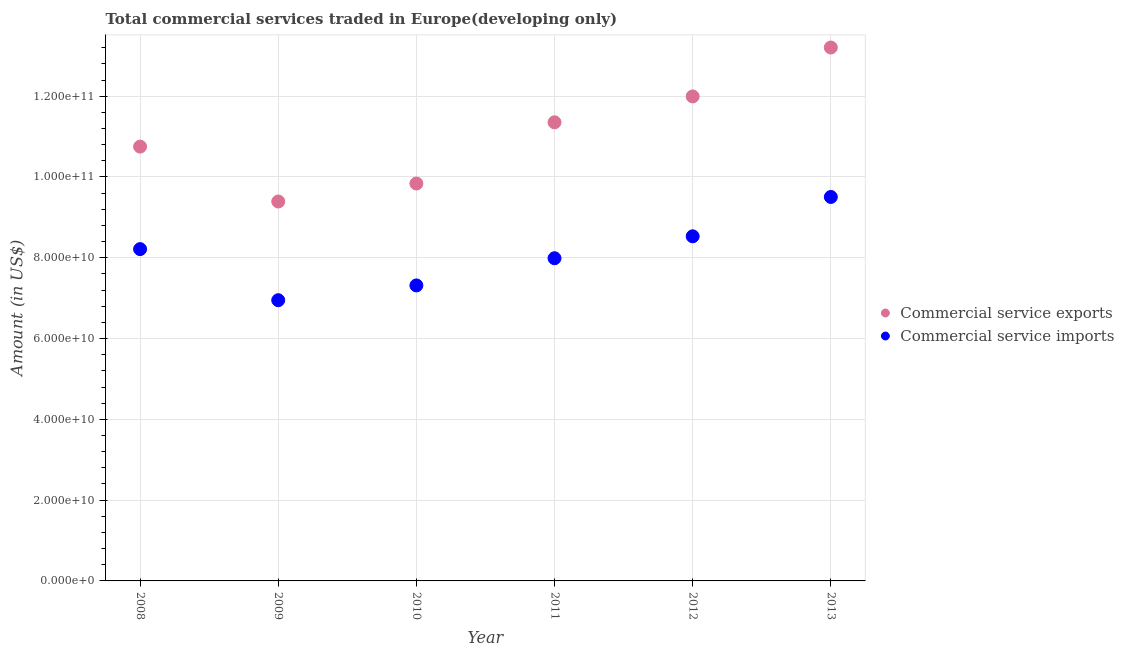How many different coloured dotlines are there?
Make the answer very short. 2. What is the amount of commercial service imports in 2011?
Give a very brief answer. 7.99e+1. Across all years, what is the maximum amount of commercial service imports?
Keep it short and to the point. 9.51e+1. Across all years, what is the minimum amount of commercial service exports?
Make the answer very short. 9.39e+1. In which year was the amount of commercial service exports maximum?
Your response must be concise. 2013. In which year was the amount of commercial service exports minimum?
Make the answer very short. 2009. What is the total amount of commercial service exports in the graph?
Your answer should be very brief. 6.65e+11. What is the difference between the amount of commercial service imports in 2008 and that in 2012?
Keep it short and to the point. -3.17e+09. What is the difference between the amount of commercial service exports in 2010 and the amount of commercial service imports in 2012?
Offer a very short reply. 1.31e+1. What is the average amount of commercial service imports per year?
Your answer should be very brief. 8.08e+1. In the year 2011, what is the difference between the amount of commercial service imports and amount of commercial service exports?
Keep it short and to the point. -3.36e+1. What is the ratio of the amount of commercial service exports in 2009 to that in 2011?
Give a very brief answer. 0.83. Is the amount of commercial service exports in 2008 less than that in 2013?
Provide a short and direct response. Yes. Is the difference between the amount of commercial service imports in 2010 and 2013 greater than the difference between the amount of commercial service exports in 2010 and 2013?
Keep it short and to the point. Yes. What is the difference between the highest and the second highest amount of commercial service exports?
Your answer should be compact. 1.21e+1. What is the difference between the highest and the lowest amount of commercial service imports?
Your answer should be very brief. 2.56e+1. Is the sum of the amount of commercial service exports in 2008 and 2010 greater than the maximum amount of commercial service imports across all years?
Make the answer very short. Yes. How many dotlines are there?
Offer a terse response. 2. How many years are there in the graph?
Offer a terse response. 6. Where does the legend appear in the graph?
Your answer should be very brief. Center right. How many legend labels are there?
Offer a terse response. 2. How are the legend labels stacked?
Offer a terse response. Vertical. What is the title of the graph?
Make the answer very short. Total commercial services traded in Europe(developing only). Does "Investment in Transport" appear as one of the legend labels in the graph?
Your response must be concise. No. What is the Amount (in US$) of Commercial service exports in 2008?
Offer a very short reply. 1.08e+11. What is the Amount (in US$) of Commercial service imports in 2008?
Provide a short and direct response. 8.21e+1. What is the Amount (in US$) of Commercial service exports in 2009?
Make the answer very short. 9.39e+1. What is the Amount (in US$) of Commercial service imports in 2009?
Your answer should be very brief. 6.95e+1. What is the Amount (in US$) in Commercial service exports in 2010?
Your response must be concise. 9.84e+1. What is the Amount (in US$) in Commercial service imports in 2010?
Give a very brief answer. 7.32e+1. What is the Amount (in US$) in Commercial service exports in 2011?
Offer a very short reply. 1.14e+11. What is the Amount (in US$) in Commercial service imports in 2011?
Offer a very short reply. 7.99e+1. What is the Amount (in US$) of Commercial service exports in 2012?
Provide a succinct answer. 1.20e+11. What is the Amount (in US$) in Commercial service imports in 2012?
Offer a terse response. 8.53e+1. What is the Amount (in US$) of Commercial service exports in 2013?
Offer a terse response. 1.32e+11. What is the Amount (in US$) in Commercial service imports in 2013?
Your answer should be very brief. 9.51e+1. Across all years, what is the maximum Amount (in US$) of Commercial service exports?
Give a very brief answer. 1.32e+11. Across all years, what is the maximum Amount (in US$) of Commercial service imports?
Offer a very short reply. 9.51e+1. Across all years, what is the minimum Amount (in US$) of Commercial service exports?
Your answer should be compact. 9.39e+1. Across all years, what is the minimum Amount (in US$) of Commercial service imports?
Your answer should be very brief. 6.95e+1. What is the total Amount (in US$) in Commercial service exports in the graph?
Offer a terse response. 6.65e+11. What is the total Amount (in US$) of Commercial service imports in the graph?
Offer a very short reply. 4.85e+11. What is the difference between the Amount (in US$) in Commercial service exports in 2008 and that in 2009?
Provide a short and direct response. 1.36e+1. What is the difference between the Amount (in US$) of Commercial service imports in 2008 and that in 2009?
Give a very brief answer. 1.26e+1. What is the difference between the Amount (in US$) in Commercial service exports in 2008 and that in 2010?
Offer a terse response. 9.14e+09. What is the difference between the Amount (in US$) in Commercial service imports in 2008 and that in 2010?
Provide a succinct answer. 8.99e+09. What is the difference between the Amount (in US$) in Commercial service exports in 2008 and that in 2011?
Provide a succinct answer. -6.02e+09. What is the difference between the Amount (in US$) of Commercial service imports in 2008 and that in 2011?
Provide a short and direct response. 2.25e+09. What is the difference between the Amount (in US$) in Commercial service exports in 2008 and that in 2012?
Make the answer very short. -1.24e+1. What is the difference between the Amount (in US$) in Commercial service imports in 2008 and that in 2012?
Your answer should be very brief. -3.17e+09. What is the difference between the Amount (in US$) in Commercial service exports in 2008 and that in 2013?
Keep it short and to the point. -2.45e+1. What is the difference between the Amount (in US$) of Commercial service imports in 2008 and that in 2013?
Ensure brevity in your answer.  -1.29e+1. What is the difference between the Amount (in US$) in Commercial service exports in 2009 and that in 2010?
Your response must be concise. -4.45e+09. What is the difference between the Amount (in US$) in Commercial service imports in 2009 and that in 2010?
Provide a succinct answer. -3.66e+09. What is the difference between the Amount (in US$) of Commercial service exports in 2009 and that in 2011?
Your response must be concise. -1.96e+1. What is the difference between the Amount (in US$) of Commercial service imports in 2009 and that in 2011?
Ensure brevity in your answer.  -1.04e+1. What is the difference between the Amount (in US$) of Commercial service exports in 2009 and that in 2012?
Keep it short and to the point. -2.60e+1. What is the difference between the Amount (in US$) of Commercial service imports in 2009 and that in 2012?
Provide a short and direct response. -1.58e+1. What is the difference between the Amount (in US$) of Commercial service exports in 2009 and that in 2013?
Provide a short and direct response. -3.81e+1. What is the difference between the Amount (in US$) of Commercial service imports in 2009 and that in 2013?
Provide a succinct answer. -2.56e+1. What is the difference between the Amount (in US$) in Commercial service exports in 2010 and that in 2011?
Provide a short and direct response. -1.52e+1. What is the difference between the Amount (in US$) of Commercial service imports in 2010 and that in 2011?
Your answer should be compact. -6.73e+09. What is the difference between the Amount (in US$) of Commercial service exports in 2010 and that in 2012?
Provide a succinct answer. -2.16e+1. What is the difference between the Amount (in US$) of Commercial service imports in 2010 and that in 2012?
Your answer should be compact. -1.22e+1. What is the difference between the Amount (in US$) of Commercial service exports in 2010 and that in 2013?
Keep it short and to the point. -3.37e+1. What is the difference between the Amount (in US$) of Commercial service imports in 2010 and that in 2013?
Your response must be concise. -2.19e+1. What is the difference between the Amount (in US$) of Commercial service exports in 2011 and that in 2012?
Ensure brevity in your answer.  -6.41e+09. What is the difference between the Amount (in US$) in Commercial service imports in 2011 and that in 2012?
Give a very brief answer. -5.42e+09. What is the difference between the Amount (in US$) of Commercial service exports in 2011 and that in 2013?
Your answer should be compact. -1.85e+1. What is the difference between the Amount (in US$) in Commercial service imports in 2011 and that in 2013?
Offer a terse response. -1.52e+1. What is the difference between the Amount (in US$) in Commercial service exports in 2012 and that in 2013?
Your answer should be very brief. -1.21e+1. What is the difference between the Amount (in US$) of Commercial service imports in 2012 and that in 2013?
Keep it short and to the point. -9.74e+09. What is the difference between the Amount (in US$) of Commercial service exports in 2008 and the Amount (in US$) of Commercial service imports in 2009?
Provide a succinct answer. 3.80e+1. What is the difference between the Amount (in US$) of Commercial service exports in 2008 and the Amount (in US$) of Commercial service imports in 2010?
Keep it short and to the point. 3.44e+1. What is the difference between the Amount (in US$) in Commercial service exports in 2008 and the Amount (in US$) in Commercial service imports in 2011?
Provide a succinct answer. 2.76e+1. What is the difference between the Amount (in US$) in Commercial service exports in 2008 and the Amount (in US$) in Commercial service imports in 2012?
Offer a very short reply. 2.22e+1. What is the difference between the Amount (in US$) of Commercial service exports in 2008 and the Amount (in US$) of Commercial service imports in 2013?
Provide a short and direct response. 1.25e+1. What is the difference between the Amount (in US$) in Commercial service exports in 2009 and the Amount (in US$) in Commercial service imports in 2010?
Give a very brief answer. 2.08e+1. What is the difference between the Amount (in US$) of Commercial service exports in 2009 and the Amount (in US$) of Commercial service imports in 2011?
Make the answer very short. 1.40e+1. What is the difference between the Amount (in US$) of Commercial service exports in 2009 and the Amount (in US$) of Commercial service imports in 2012?
Your response must be concise. 8.61e+09. What is the difference between the Amount (in US$) in Commercial service exports in 2009 and the Amount (in US$) in Commercial service imports in 2013?
Ensure brevity in your answer.  -1.13e+09. What is the difference between the Amount (in US$) of Commercial service exports in 2010 and the Amount (in US$) of Commercial service imports in 2011?
Give a very brief answer. 1.85e+1. What is the difference between the Amount (in US$) in Commercial service exports in 2010 and the Amount (in US$) in Commercial service imports in 2012?
Give a very brief answer. 1.31e+1. What is the difference between the Amount (in US$) of Commercial service exports in 2010 and the Amount (in US$) of Commercial service imports in 2013?
Provide a short and direct response. 3.32e+09. What is the difference between the Amount (in US$) of Commercial service exports in 2011 and the Amount (in US$) of Commercial service imports in 2012?
Provide a short and direct response. 2.82e+1. What is the difference between the Amount (in US$) of Commercial service exports in 2011 and the Amount (in US$) of Commercial service imports in 2013?
Offer a very short reply. 1.85e+1. What is the difference between the Amount (in US$) of Commercial service exports in 2012 and the Amount (in US$) of Commercial service imports in 2013?
Make the answer very short. 2.49e+1. What is the average Amount (in US$) in Commercial service exports per year?
Provide a short and direct response. 1.11e+11. What is the average Amount (in US$) in Commercial service imports per year?
Offer a very short reply. 8.08e+1. In the year 2008, what is the difference between the Amount (in US$) of Commercial service exports and Amount (in US$) of Commercial service imports?
Keep it short and to the point. 2.54e+1. In the year 2009, what is the difference between the Amount (in US$) in Commercial service exports and Amount (in US$) in Commercial service imports?
Provide a short and direct response. 2.44e+1. In the year 2010, what is the difference between the Amount (in US$) in Commercial service exports and Amount (in US$) in Commercial service imports?
Provide a short and direct response. 2.52e+1. In the year 2011, what is the difference between the Amount (in US$) in Commercial service exports and Amount (in US$) in Commercial service imports?
Ensure brevity in your answer.  3.36e+1. In the year 2012, what is the difference between the Amount (in US$) in Commercial service exports and Amount (in US$) in Commercial service imports?
Provide a succinct answer. 3.46e+1. In the year 2013, what is the difference between the Amount (in US$) of Commercial service exports and Amount (in US$) of Commercial service imports?
Offer a terse response. 3.70e+1. What is the ratio of the Amount (in US$) in Commercial service exports in 2008 to that in 2009?
Keep it short and to the point. 1.14. What is the ratio of the Amount (in US$) in Commercial service imports in 2008 to that in 2009?
Make the answer very short. 1.18. What is the ratio of the Amount (in US$) in Commercial service exports in 2008 to that in 2010?
Your answer should be compact. 1.09. What is the ratio of the Amount (in US$) in Commercial service imports in 2008 to that in 2010?
Provide a succinct answer. 1.12. What is the ratio of the Amount (in US$) in Commercial service exports in 2008 to that in 2011?
Keep it short and to the point. 0.95. What is the ratio of the Amount (in US$) of Commercial service imports in 2008 to that in 2011?
Make the answer very short. 1.03. What is the ratio of the Amount (in US$) of Commercial service exports in 2008 to that in 2012?
Your answer should be very brief. 0.9. What is the ratio of the Amount (in US$) of Commercial service imports in 2008 to that in 2012?
Provide a succinct answer. 0.96. What is the ratio of the Amount (in US$) of Commercial service exports in 2008 to that in 2013?
Your response must be concise. 0.81. What is the ratio of the Amount (in US$) in Commercial service imports in 2008 to that in 2013?
Your response must be concise. 0.86. What is the ratio of the Amount (in US$) of Commercial service exports in 2009 to that in 2010?
Ensure brevity in your answer.  0.95. What is the ratio of the Amount (in US$) of Commercial service exports in 2009 to that in 2011?
Provide a succinct answer. 0.83. What is the ratio of the Amount (in US$) in Commercial service imports in 2009 to that in 2011?
Offer a very short reply. 0.87. What is the ratio of the Amount (in US$) of Commercial service exports in 2009 to that in 2012?
Keep it short and to the point. 0.78. What is the ratio of the Amount (in US$) of Commercial service imports in 2009 to that in 2012?
Offer a terse response. 0.81. What is the ratio of the Amount (in US$) in Commercial service exports in 2009 to that in 2013?
Offer a very short reply. 0.71. What is the ratio of the Amount (in US$) in Commercial service imports in 2009 to that in 2013?
Ensure brevity in your answer.  0.73. What is the ratio of the Amount (in US$) of Commercial service exports in 2010 to that in 2011?
Your answer should be compact. 0.87. What is the ratio of the Amount (in US$) of Commercial service imports in 2010 to that in 2011?
Ensure brevity in your answer.  0.92. What is the ratio of the Amount (in US$) of Commercial service exports in 2010 to that in 2012?
Your answer should be compact. 0.82. What is the ratio of the Amount (in US$) in Commercial service imports in 2010 to that in 2012?
Provide a short and direct response. 0.86. What is the ratio of the Amount (in US$) of Commercial service exports in 2010 to that in 2013?
Make the answer very short. 0.74. What is the ratio of the Amount (in US$) in Commercial service imports in 2010 to that in 2013?
Make the answer very short. 0.77. What is the ratio of the Amount (in US$) of Commercial service exports in 2011 to that in 2012?
Make the answer very short. 0.95. What is the ratio of the Amount (in US$) in Commercial service imports in 2011 to that in 2012?
Ensure brevity in your answer.  0.94. What is the ratio of the Amount (in US$) in Commercial service exports in 2011 to that in 2013?
Ensure brevity in your answer.  0.86. What is the ratio of the Amount (in US$) in Commercial service imports in 2011 to that in 2013?
Make the answer very short. 0.84. What is the ratio of the Amount (in US$) in Commercial service exports in 2012 to that in 2013?
Your response must be concise. 0.91. What is the ratio of the Amount (in US$) in Commercial service imports in 2012 to that in 2013?
Provide a short and direct response. 0.9. What is the difference between the highest and the second highest Amount (in US$) in Commercial service exports?
Your answer should be very brief. 1.21e+1. What is the difference between the highest and the second highest Amount (in US$) in Commercial service imports?
Offer a very short reply. 9.74e+09. What is the difference between the highest and the lowest Amount (in US$) in Commercial service exports?
Ensure brevity in your answer.  3.81e+1. What is the difference between the highest and the lowest Amount (in US$) of Commercial service imports?
Provide a succinct answer. 2.56e+1. 